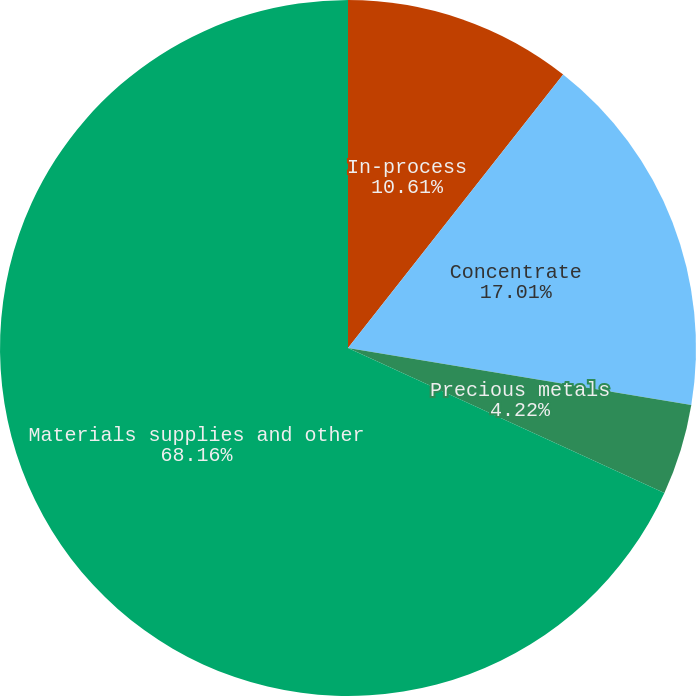<chart> <loc_0><loc_0><loc_500><loc_500><pie_chart><fcel>In-process<fcel>Concentrate<fcel>Precious metals<fcel>Materials supplies and other<nl><fcel>10.61%<fcel>17.01%<fcel>4.22%<fcel>68.17%<nl></chart> 